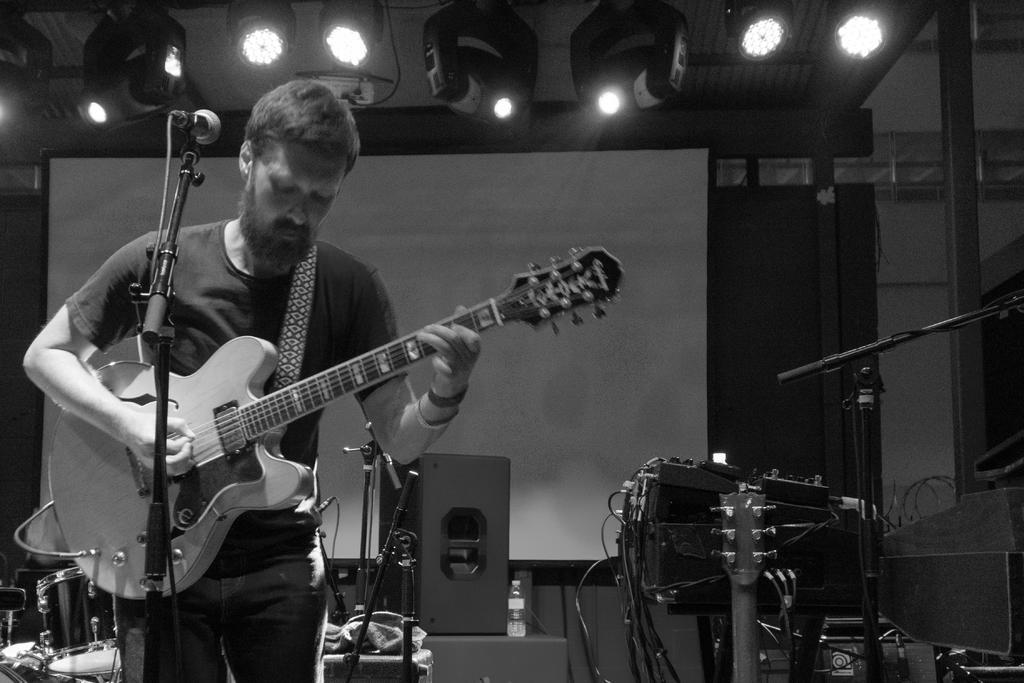In one or two sentences, can you explain what this image depicts? A man is standing by holding a guitar in his hands. There are lights at the top. 